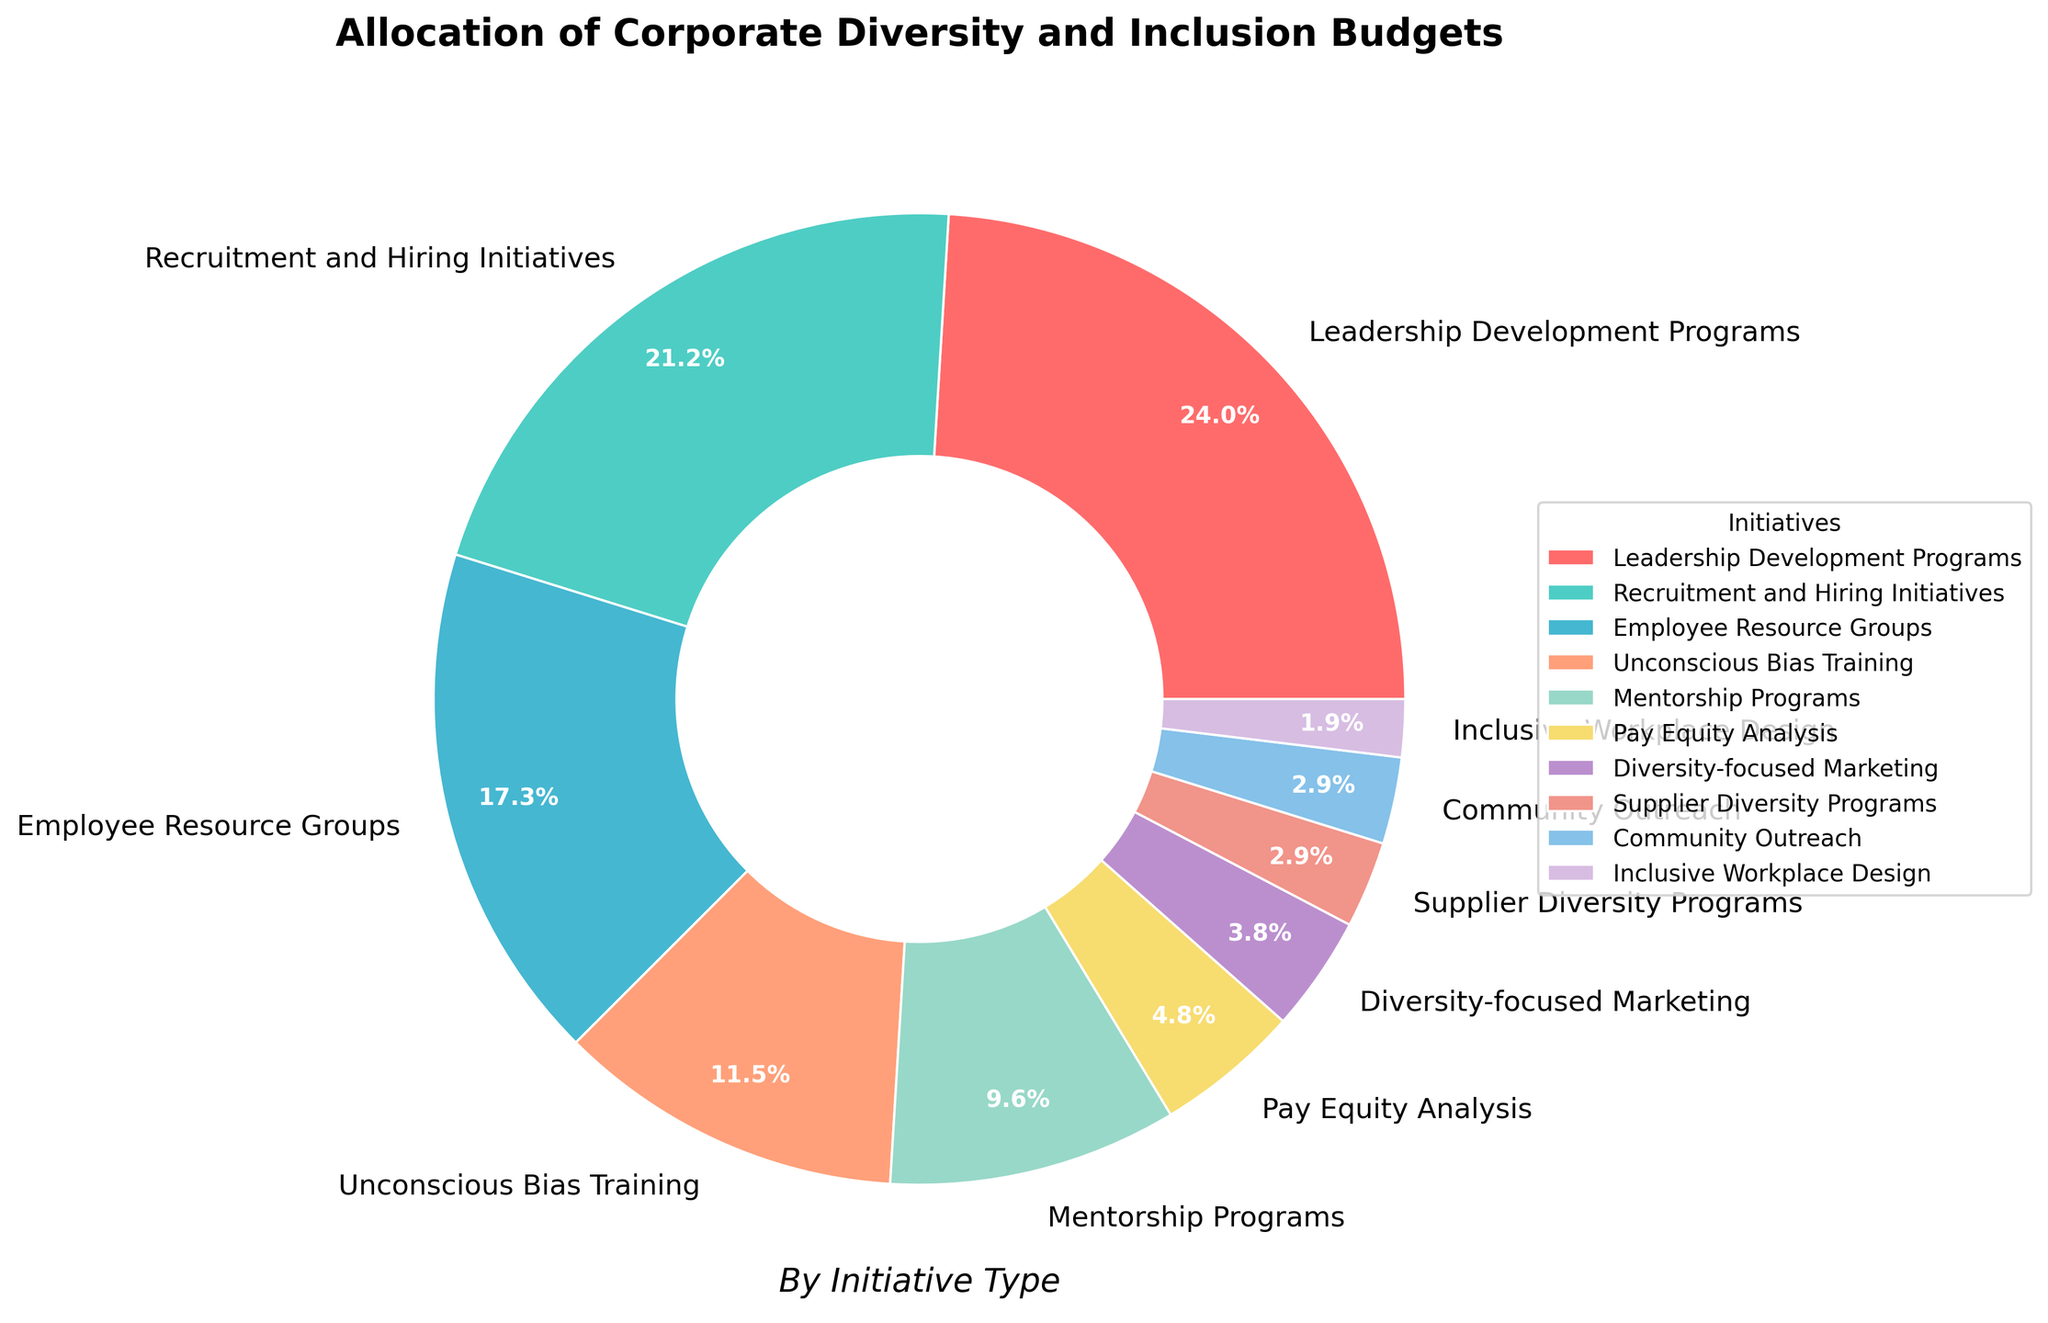What's the largest allocation category? To determine the largest allocation category, look at the wedge with the biggest size in the pie chart. The label attached to this wedge indicates the category.
Answer: Leadership Development Programs What's the combined percentage allocated to Recruitment and Hiring Initiatives and Mentorship Programs? To find the combined percentage, add the percentages of both categories: Recruitment and Hiring Initiatives (22%) + Mentorship Programs (10%).
Answer: 32% Which category has the smallest budget allocation? Look for the smallest wedge in the pie chart and check the associated label.
Answer: Inclusive Workplace Design Are there any categories that share an equal percentage allocation? Review the wedges in the pie chart to see if two or more wedges correspond to the same percentage of the overall budget. Community Outreach and Supplier Diversity Programs both have a 3% allocation.
Answer: Community Outreach, Supplier Diversity Programs What's the ratio of the budget allocation between Unconscious Bias Training and Employee Resource Groups? To find the ratio, divide the percentage allocation for Unconscious Bias Training (12%) by the allocation for Employee Resource Groups (18%). The fraction gives us 12/18, which simplifies to 2/3.
Answer: 2:3 What is the total percentage allocated to initiatives not related to leadership? Sum the percentages of categories excluding Leadership Development Programs (25%): 22% + 18% + 12% + 10% + 5% + 4% + 3% + 3% + 2%. This sums up to 79%.
Answer: 79% Which initiative is represented by the wedge that is colored blue? Check the pie chart legend for the initiative name corresponding to the blue-colored wedge. Employee Resource Groups are represented by the blue wedge.
Answer: Employee Resource Groups Compare the combined budget allocation for Mentorship Programs and Pay Equity Analysis with that of Recruitment and Hiring Initiatives. Which is higher? Add the percentages for Mentorship Programs (10%) and Pay Equity Analysis (5%) to get 15%. Compare this to Recruitment and Hiring Initiatives (22%). Recruitment and Hiring Initiatives has the higher allocation.
Answer: Recruitment and Hiring Initiatives What percentage is dedicated to initiatives focusing directly on workplace inclusivity (not including diversity training)? Sum the percentages of Inclusive Workplace Design (2%) and Employee Resource Groups (18%). The total is 20%.
Answer: 20% 